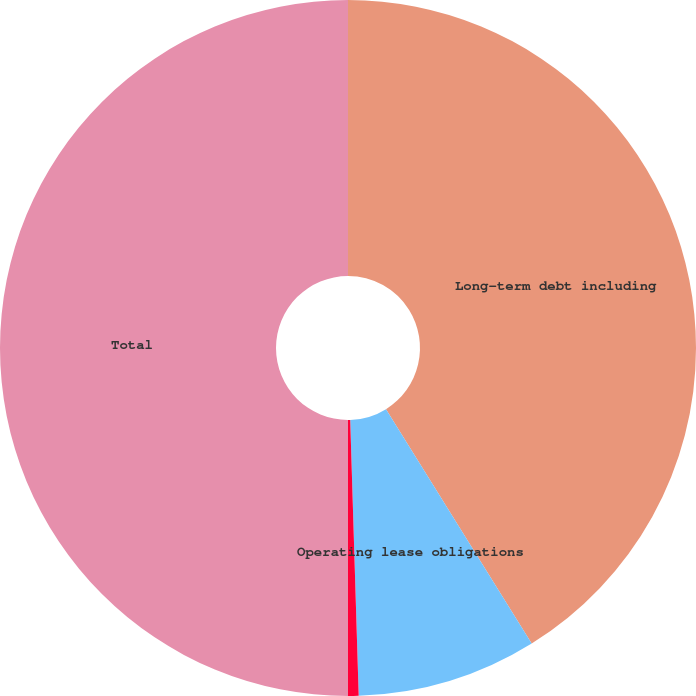Convert chart. <chart><loc_0><loc_0><loc_500><loc_500><pie_chart><fcel>Long-term debt including<fcel>Operating lease obligations<fcel>Purchase obligations^(2)<fcel>Total<nl><fcel>41.15%<fcel>8.36%<fcel>0.49%<fcel>50.0%<nl></chart> 